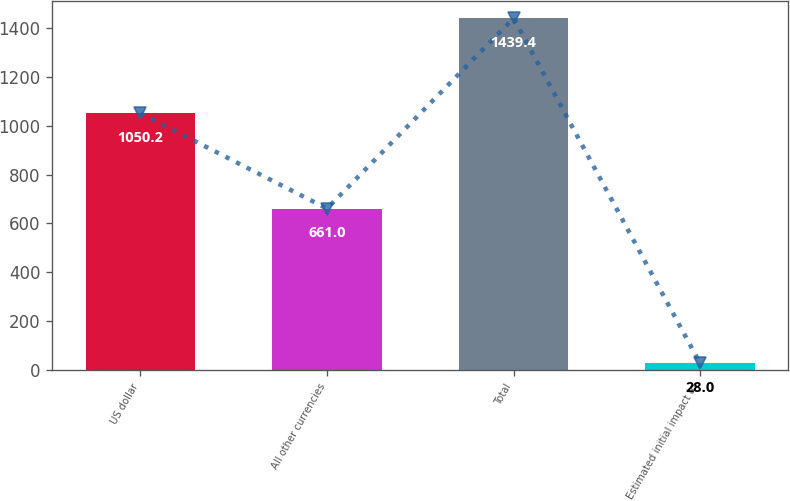<chart> <loc_0><loc_0><loc_500><loc_500><bar_chart><fcel>US dollar<fcel>All other currencies<fcel>Total<fcel>Estimated initial impact to<nl><fcel>1050.2<fcel>661<fcel>1439.4<fcel>28<nl></chart> 